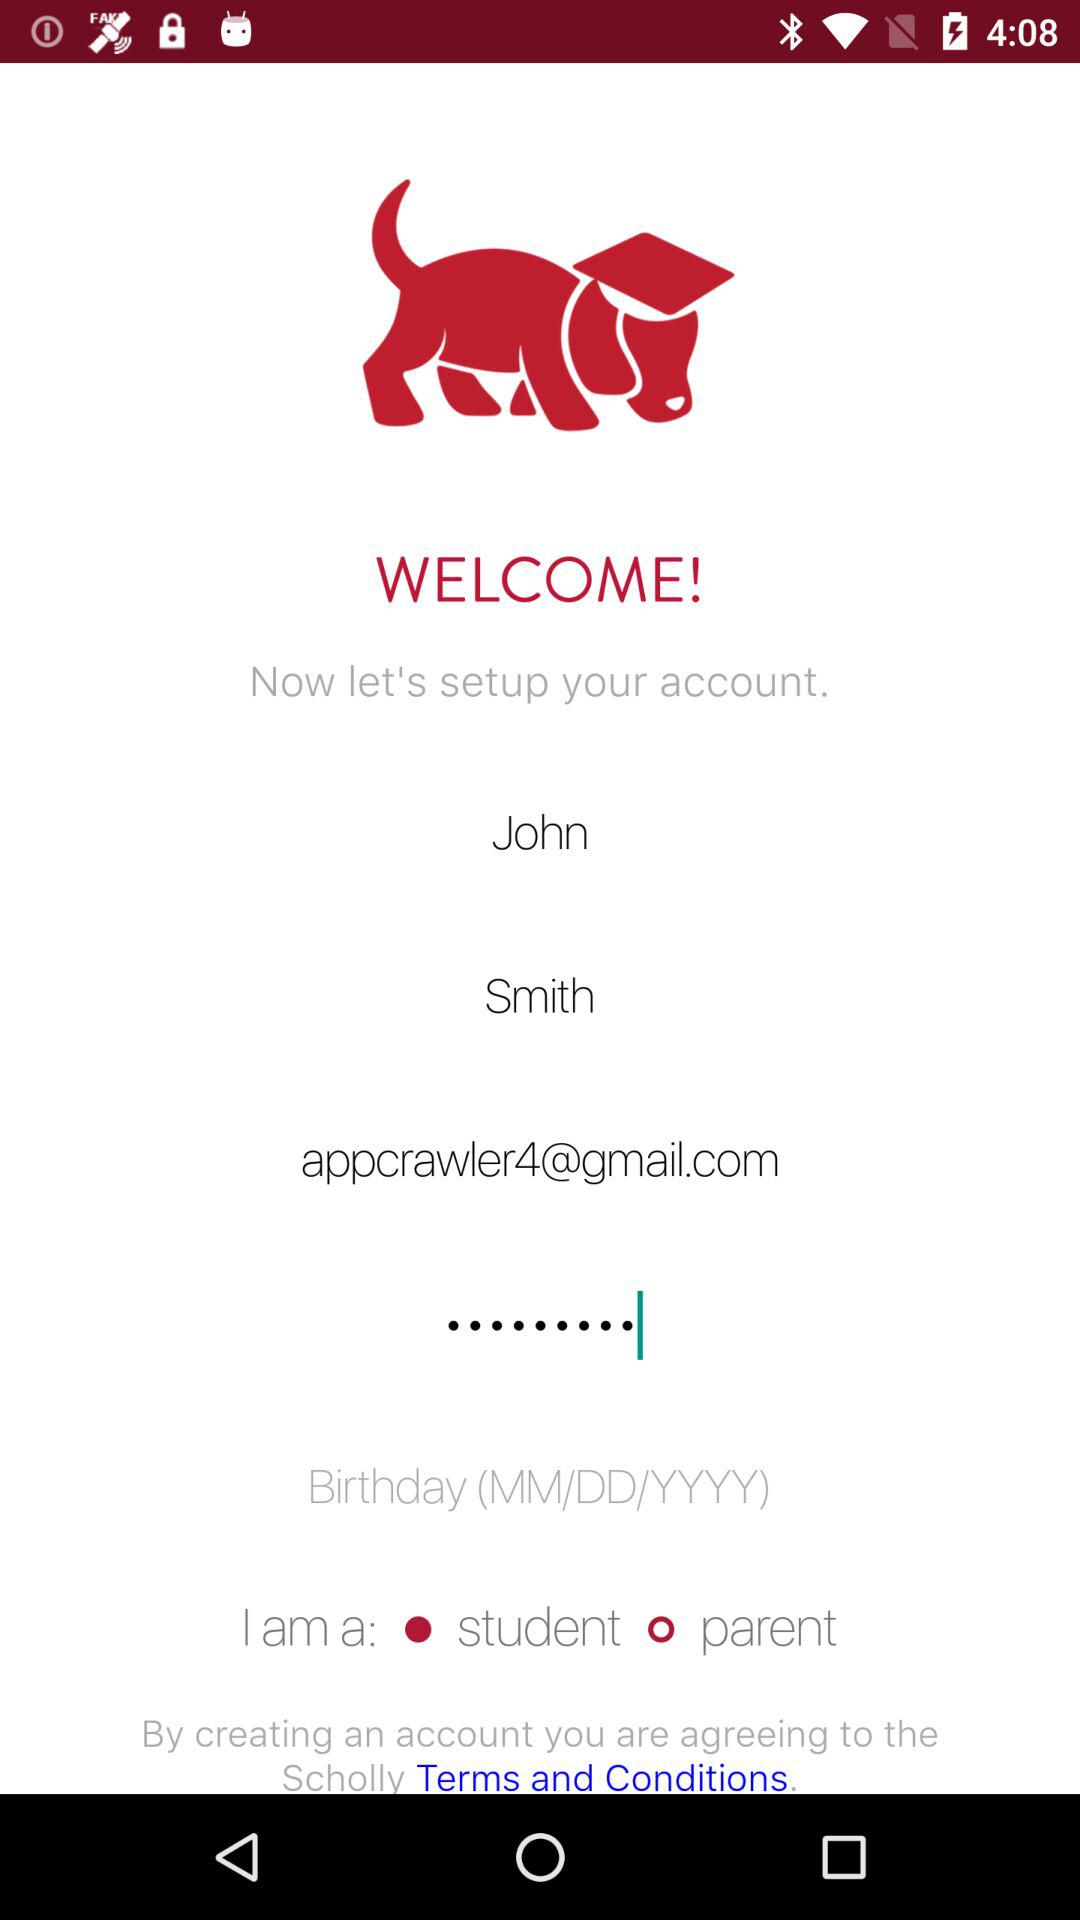Which option is selected? The selected option is "student". 